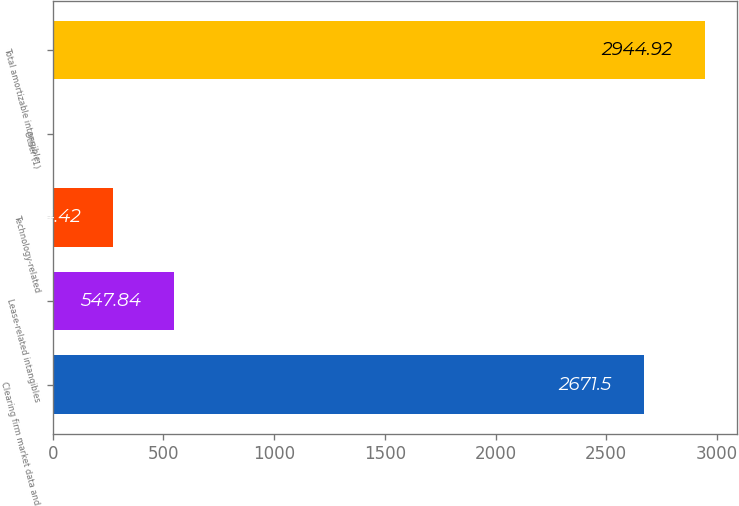Convert chart to OTSL. <chart><loc_0><loc_0><loc_500><loc_500><bar_chart><fcel>Clearing firm market data and<fcel>Lease-related intangibles<fcel>Technology-related<fcel>Other (1)<fcel>Total amortizable intangible<nl><fcel>2671.5<fcel>547.84<fcel>274.42<fcel>1<fcel>2944.92<nl></chart> 